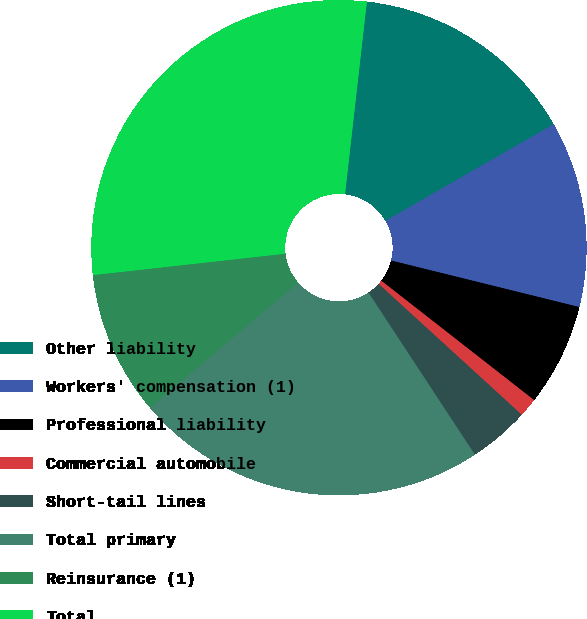Convert chart to OTSL. <chart><loc_0><loc_0><loc_500><loc_500><pie_chart><fcel>Other liability<fcel>Workers' compensation (1)<fcel>Professional liability<fcel>Commercial automobile<fcel>Short-tail lines<fcel>Total primary<fcel>Reinsurance (1)<fcel>Total<nl><fcel>14.9%<fcel>12.16%<fcel>6.7%<fcel>1.23%<fcel>3.97%<fcel>23.05%<fcel>9.43%<fcel>28.56%<nl></chart> 